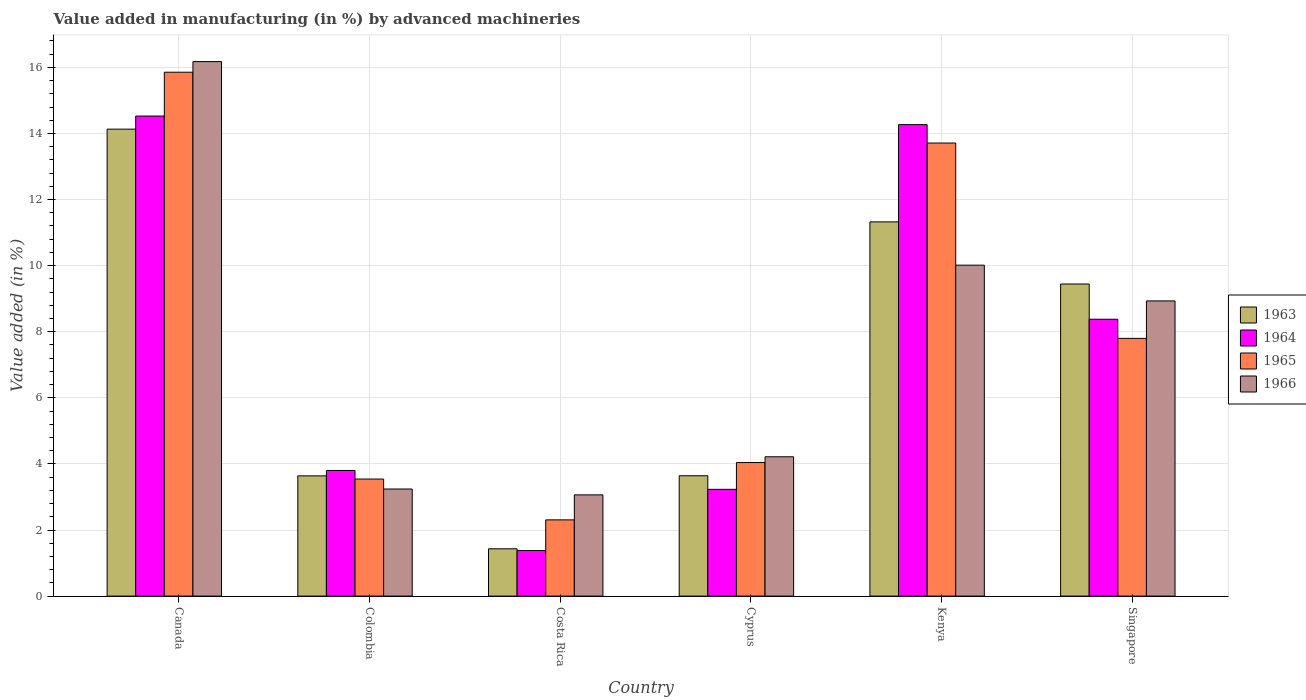How many different coloured bars are there?
Your response must be concise. 4. How many groups of bars are there?
Provide a short and direct response. 6. Are the number of bars per tick equal to the number of legend labels?
Ensure brevity in your answer.  Yes. How many bars are there on the 1st tick from the left?
Offer a terse response. 4. What is the label of the 6th group of bars from the left?
Give a very brief answer. Singapore. In how many cases, is the number of bars for a given country not equal to the number of legend labels?
Give a very brief answer. 0. What is the percentage of value added in manufacturing by advanced machineries in 1965 in Colombia?
Offer a very short reply. 3.54. Across all countries, what is the maximum percentage of value added in manufacturing by advanced machineries in 1966?
Your answer should be very brief. 16.17. Across all countries, what is the minimum percentage of value added in manufacturing by advanced machineries in 1966?
Make the answer very short. 3.06. In which country was the percentage of value added in manufacturing by advanced machineries in 1965 maximum?
Give a very brief answer. Canada. What is the total percentage of value added in manufacturing by advanced machineries in 1965 in the graph?
Offer a very short reply. 47.25. What is the difference between the percentage of value added in manufacturing by advanced machineries in 1965 in Colombia and that in Singapore?
Offer a terse response. -4.26. What is the difference between the percentage of value added in manufacturing by advanced machineries in 1966 in Costa Rica and the percentage of value added in manufacturing by advanced machineries in 1963 in Canada?
Make the answer very short. -11.07. What is the average percentage of value added in manufacturing by advanced machineries in 1964 per country?
Your answer should be compact. 7.6. What is the difference between the percentage of value added in manufacturing by advanced machineries of/in 1965 and percentage of value added in manufacturing by advanced machineries of/in 1963 in Cyprus?
Provide a short and direct response. 0.4. In how many countries, is the percentage of value added in manufacturing by advanced machineries in 1966 greater than 2 %?
Ensure brevity in your answer.  6. What is the ratio of the percentage of value added in manufacturing by advanced machineries in 1965 in Canada to that in Singapore?
Ensure brevity in your answer.  2.03. Is the percentage of value added in manufacturing by advanced machineries in 1966 in Colombia less than that in Costa Rica?
Ensure brevity in your answer.  No. What is the difference between the highest and the second highest percentage of value added in manufacturing by advanced machineries in 1963?
Provide a succinct answer. -1.88. What is the difference between the highest and the lowest percentage of value added in manufacturing by advanced machineries in 1964?
Offer a terse response. 13.15. In how many countries, is the percentage of value added in manufacturing by advanced machineries in 1963 greater than the average percentage of value added in manufacturing by advanced machineries in 1963 taken over all countries?
Provide a succinct answer. 3. Is it the case that in every country, the sum of the percentage of value added in manufacturing by advanced machineries in 1963 and percentage of value added in manufacturing by advanced machineries in 1964 is greater than the sum of percentage of value added in manufacturing by advanced machineries in 1965 and percentage of value added in manufacturing by advanced machineries in 1966?
Make the answer very short. No. What does the 1st bar from the left in Colombia represents?
Provide a short and direct response. 1963. What does the 3rd bar from the right in Costa Rica represents?
Give a very brief answer. 1964. Is it the case that in every country, the sum of the percentage of value added in manufacturing by advanced machineries in 1966 and percentage of value added in manufacturing by advanced machineries in 1965 is greater than the percentage of value added in manufacturing by advanced machineries in 1964?
Your response must be concise. Yes. What is the difference between two consecutive major ticks on the Y-axis?
Provide a short and direct response. 2. Are the values on the major ticks of Y-axis written in scientific E-notation?
Provide a short and direct response. No. How many legend labels are there?
Provide a succinct answer. 4. How are the legend labels stacked?
Provide a short and direct response. Vertical. What is the title of the graph?
Your response must be concise. Value added in manufacturing (in %) by advanced machineries. What is the label or title of the X-axis?
Make the answer very short. Country. What is the label or title of the Y-axis?
Keep it short and to the point. Value added (in %). What is the Value added (in %) of 1963 in Canada?
Provide a succinct answer. 14.13. What is the Value added (in %) in 1964 in Canada?
Your response must be concise. 14.53. What is the Value added (in %) of 1965 in Canada?
Your response must be concise. 15.85. What is the Value added (in %) in 1966 in Canada?
Your response must be concise. 16.17. What is the Value added (in %) of 1963 in Colombia?
Offer a terse response. 3.64. What is the Value added (in %) of 1964 in Colombia?
Keep it short and to the point. 3.8. What is the Value added (in %) of 1965 in Colombia?
Ensure brevity in your answer.  3.54. What is the Value added (in %) in 1966 in Colombia?
Provide a short and direct response. 3.24. What is the Value added (in %) in 1963 in Costa Rica?
Keep it short and to the point. 1.43. What is the Value added (in %) in 1964 in Costa Rica?
Your answer should be very brief. 1.38. What is the Value added (in %) of 1965 in Costa Rica?
Keep it short and to the point. 2.31. What is the Value added (in %) in 1966 in Costa Rica?
Keep it short and to the point. 3.06. What is the Value added (in %) of 1963 in Cyprus?
Provide a short and direct response. 3.64. What is the Value added (in %) of 1964 in Cyprus?
Keep it short and to the point. 3.23. What is the Value added (in %) in 1965 in Cyprus?
Provide a succinct answer. 4.04. What is the Value added (in %) of 1966 in Cyprus?
Offer a very short reply. 4.22. What is the Value added (in %) in 1963 in Kenya?
Your response must be concise. 11.32. What is the Value added (in %) of 1964 in Kenya?
Provide a short and direct response. 14.27. What is the Value added (in %) of 1965 in Kenya?
Offer a very short reply. 13.71. What is the Value added (in %) in 1966 in Kenya?
Your answer should be compact. 10.01. What is the Value added (in %) of 1963 in Singapore?
Provide a succinct answer. 9.44. What is the Value added (in %) of 1964 in Singapore?
Offer a terse response. 8.38. What is the Value added (in %) in 1965 in Singapore?
Give a very brief answer. 7.8. What is the Value added (in %) of 1966 in Singapore?
Make the answer very short. 8.93. Across all countries, what is the maximum Value added (in %) in 1963?
Offer a very short reply. 14.13. Across all countries, what is the maximum Value added (in %) in 1964?
Your answer should be compact. 14.53. Across all countries, what is the maximum Value added (in %) of 1965?
Provide a short and direct response. 15.85. Across all countries, what is the maximum Value added (in %) in 1966?
Make the answer very short. 16.17. Across all countries, what is the minimum Value added (in %) of 1963?
Your answer should be compact. 1.43. Across all countries, what is the minimum Value added (in %) in 1964?
Keep it short and to the point. 1.38. Across all countries, what is the minimum Value added (in %) of 1965?
Provide a succinct answer. 2.31. Across all countries, what is the minimum Value added (in %) in 1966?
Provide a short and direct response. 3.06. What is the total Value added (in %) in 1963 in the graph?
Keep it short and to the point. 43.61. What is the total Value added (in %) of 1964 in the graph?
Your answer should be compact. 45.58. What is the total Value added (in %) in 1965 in the graph?
Provide a short and direct response. 47.25. What is the total Value added (in %) of 1966 in the graph?
Give a very brief answer. 45.64. What is the difference between the Value added (in %) of 1963 in Canada and that in Colombia?
Your answer should be compact. 10.49. What is the difference between the Value added (in %) of 1964 in Canada and that in Colombia?
Ensure brevity in your answer.  10.72. What is the difference between the Value added (in %) in 1965 in Canada and that in Colombia?
Your answer should be compact. 12.31. What is the difference between the Value added (in %) in 1966 in Canada and that in Colombia?
Make the answer very short. 12.93. What is the difference between the Value added (in %) of 1963 in Canada and that in Costa Rica?
Keep it short and to the point. 12.7. What is the difference between the Value added (in %) in 1964 in Canada and that in Costa Rica?
Ensure brevity in your answer.  13.15. What is the difference between the Value added (in %) of 1965 in Canada and that in Costa Rica?
Give a very brief answer. 13.55. What is the difference between the Value added (in %) in 1966 in Canada and that in Costa Rica?
Your answer should be compact. 13.11. What is the difference between the Value added (in %) in 1963 in Canada and that in Cyprus?
Make the answer very short. 10.49. What is the difference between the Value added (in %) in 1964 in Canada and that in Cyprus?
Provide a short and direct response. 11.3. What is the difference between the Value added (in %) in 1965 in Canada and that in Cyprus?
Provide a succinct answer. 11.81. What is the difference between the Value added (in %) in 1966 in Canada and that in Cyprus?
Keep it short and to the point. 11.96. What is the difference between the Value added (in %) in 1963 in Canada and that in Kenya?
Give a very brief answer. 2.81. What is the difference between the Value added (in %) of 1964 in Canada and that in Kenya?
Your answer should be compact. 0.26. What is the difference between the Value added (in %) in 1965 in Canada and that in Kenya?
Offer a terse response. 2.14. What is the difference between the Value added (in %) of 1966 in Canada and that in Kenya?
Give a very brief answer. 6.16. What is the difference between the Value added (in %) in 1963 in Canada and that in Singapore?
Offer a very short reply. 4.69. What is the difference between the Value added (in %) in 1964 in Canada and that in Singapore?
Your answer should be compact. 6.15. What is the difference between the Value added (in %) of 1965 in Canada and that in Singapore?
Ensure brevity in your answer.  8.05. What is the difference between the Value added (in %) of 1966 in Canada and that in Singapore?
Keep it short and to the point. 7.24. What is the difference between the Value added (in %) of 1963 in Colombia and that in Costa Rica?
Keep it short and to the point. 2.21. What is the difference between the Value added (in %) of 1964 in Colombia and that in Costa Rica?
Your answer should be very brief. 2.42. What is the difference between the Value added (in %) in 1965 in Colombia and that in Costa Rica?
Keep it short and to the point. 1.24. What is the difference between the Value added (in %) of 1966 in Colombia and that in Costa Rica?
Provide a short and direct response. 0.18. What is the difference between the Value added (in %) in 1963 in Colombia and that in Cyprus?
Give a very brief answer. -0. What is the difference between the Value added (in %) in 1964 in Colombia and that in Cyprus?
Offer a terse response. 0.57. What is the difference between the Value added (in %) in 1965 in Colombia and that in Cyprus?
Keep it short and to the point. -0.5. What is the difference between the Value added (in %) in 1966 in Colombia and that in Cyprus?
Provide a short and direct response. -0.97. What is the difference between the Value added (in %) of 1963 in Colombia and that in Kenya?
Your answer should be very brief. -7.69. What is the difference between the Value added (in %) in 1964 in Colombia and that in Kenya?
Keep it short and to the point. -10.47. What is the difference between the Value added (in %) in 1965 in Colombia and that in Kenya?
Your answer should be compact. -10.17. What is the difference between the Value added (in %) of 1966 in Colombia and that in Kenya?
Offer a very short reply. -6.77. What is the difference between the Value added (in %) of 1963 in Colombia and that in Singapore?
Make the answer very short. -5.81. What is the difference between the Value added (in %) in 1964 in Colombia and that in Singapore?
Keep it short and to the point. -4.58. What is the difference between the Value added (in %) in 1965 in Colombia and that in Singapore?
Your answer should be compact. -4.26. What is the difference between the Value added (in %) in 1966 in Colombia and that in Singapore?
Ensure brevity in your answer.  -5.69. What is the difference between the Value added (in %) in 1963 in Costa Rica and that in Cyprus?
Make the answer very short. -2.21. What is the difference between the Value added (in %) of 1964 in Costa Rica and that in Cyprus?
Keep it short and to the point. -1.85. What is the difference between the Value added (in %) of 1965 in Costa Rica and that in Cyprus?
Give a very brief answer. -1.73. What is the difference between the Value added (in %) in 1966 in Costa Rica and that in Cyprus?
Keep it short and to the point. -1.15. What is the difference between the Value added (in %) of 1963 in Costa Rica and that in Kenya?
Your response must be concise. -9.89. What is the difference between the Value added (in %) of 1964 in Costa Rica and that in Kenya?
Offer a very short reply. -12.89. What is the difference between the Value added (in %) of 1965 in Costa Rica and that in Kenya?
Make the answer very short. -11.4. What is the difference between the Value added (in %) of 1966 in Costa Rica and that in Kenya?
Ensure brevity in your answer.  -6.95. What is the difference between the Value added (in %) of 1963 in Costa Rica and that in Singapore?
Give a very brief answer. -8.01. What is the difference between the Value added (in %) of 1964 in Costa Rica and that in Singapore?
Offer a very short reply. -7. What is the difference between the Value added (in %) of 1965 in Costa Rica and that in Singapore?
Provide a succinct answer. -5.49. What is the difference between the Value added (in %) of 1966 in Costa Rica and that in Singapore?
Your response must be concise. -5.87. What is the difference between the Value added (in %) of 1963 in Cyprus and that in Kenya?
Ensure brevity in your answer.  -7.68. What is the difference between the Value added (in %) in 1964 in Cyprus and that in Kenya?
Keep it short and to the point. -11.04. What is the difference between the Value added (in %) in 1965 in Cyprus and that in Kenya?
Provide a succinct answer. -9.67. What is the difference between the Value added (in %) in 1966 in Cyprus and that in Kenya?
Offer a terse response. -5.8. What is the difference between the Value added (in %) in 1963 in Cyprus and that in Singapore?
Offer a very short reply. -5.8. What is the difference between the Value added (in %) of 1964 in Cyprus and that in Singapore?
Your response must be concise. -5.15. What is the difference between the Value added (in %) of 1965 in Cyprus and that in Singapore?
Provide a succinct answer. -3.76. What is the difference between the Value added (in %) in 1966 in Cyprus and that in Singapore?
Your answer should be compact. -4.72. What is the difference between the Value added (in %) in 1963 in Kenya and that in Singapore?
Ensure brevity in your answer.  1.88. What is the difference between the Value added (in %) in 1964 in Kenya and that in Singapore?
Give a very brief answer. 5.89. What is the difference between the Value added (in %) of 1965 in Kenya and that in Singapore?
Your response must be concise. 5.91. What is the difference between the Value added (in %) of 1966 in Kenya and that in Singapore?
Make the answer very short. 1.08. What is the difference between the Value added (in %) in 1963 in Canada and the Value added (in %) in 1964 in Colombia?
Your response must be concise. 10.33. What is the difference between the Value added (in %) in 1963 in Canada and the Value added (in %) in 1965 in Colombia?
Your response must be concise. 10.59. What is the difference between the Value added (in %) of 1963 in Canada and the Value added (in %) of 1966 in Colombia?
Give a very brief answer. 10.89. What is the difference between the Value added (in %) in 1964 in Canada and the Value added (in %) in 1965 in Colombia?
Ensure brevity in your answer.  10.98. What is the difference between the Value added (in %) of 1964 in Canada and the Value added (in %) of 1966 in Colombia?
Give a very brief answer. 11.29. What is the difference between the Value added (in %) of 1965 in Canada and the Value added (in %) of 1966 in Colombia?
Provide a short and direct response. 12.61. What is the difference between the Value added (in %) of 1963 in Canada and the Value added (in %) of 1964 in Costa Rica?
Make the answer very short. 12.75. What is the difference between the Value added (in %) in 1963 in Canada and the Value added (in %) in 1965 in Costa Rica?
Offer a very short reply. 11.82. What is the difference between the Value added (in %) in 1963 in Canada and the Value added (in %) in 1966 in Costa Rica?
Your response must be concise. 11.07. What is the difference between the Value added (in %) in 1964 in Canada and the Value added (in %) in 1965 in Costa Rica?
Offer a terse response. 12.22. What is the difference between the Value added (in %) in 1964 in Canada and the Value added (in %) in 1966 in Costa Rica?
Offer a terse response. 11.46. What is the difference between the Value added (in %) of 1965 in Canada and the Value added (in %) of 1966 in Costa Rica?
Offer a very short reply. 12.79. What is the difference between the Value added (in %) in 1963 in Canada and the Value added (in %) in 1964 in Cyprus?
Your answer should be compact. 10.9. What is the difference between the Value added (in %) of 1963 in Canada and the Value added (in %) of 1965 in Cyprus?
Give a very brief answer. 10.09. What is the difference between the Value added (in %) in 1963 in Canada and the Value added (in %) in 1966 in Cyprus?
Your answer should be very brief. 9.92. What is the difference between the Value added (in %) in 1964 in Canada and the Value added (in %) in 1965 in Cyprus?
Your response must be concise. 10.49. What is the difference between the Value added (in %) in 1964 in Canada and the Value added (in %) in 1966 in Cyprus?
Provide a short and direct response. 10.31. What is the difference between the Value added (in %) in 1965 in Canada and the Value added (in %) in 1966 in Cyprus?
Give a very brief answer. 11.64. What is the difference between the Value added (in %) in 1963 in Canada and the Value added (in %) in 1964 in Kenya?
Give a very brief answer. -0.14. What is the difference between the Value added (in %) in 1963 in Canada and the Value added (in %) in 1965 in Kenya?
Provide a short and direct response. 0.42. What is the difference between the Value added (in %) of 1963 in Canada and the Value added (in %) of 1966 in Kenya?
Provide a succinct answer. 4.12. What is the difference between the Value added (in %) in 1964 in Canada and the Value added (in %) in 1965 in Kenya?
Your response must be concise. 0.82. What is the difference between the Value added (in %) in 1964 in Canada and the Value added (in %) in 1966 in Kenya?
Offer a very short reply. 4.51. What is the difference between the Value added (in %) of 1965 in Canada and the Value added (in %) of 1966 in Kenya?
Give a very brief answer. 5.84. What is the difference between the Value added (in %) in 1963 in Canada and the Value added (in %) in 1964 in Singapore?
Provide a short and direct response. 5.75. What is the difference between the Value added (in %) in 1963 in Canada and the Value added (in %) in 1965 in Singapore?
Your answer should be very brief. 6.33. What is the difference between the Value added (in %) in 1963 in Canada and the Value added (in %) in 1966 in Singapore?
Provide a succinct answer. 5.2. What is the difference between the Value added (in %) of 1964 in Canada and the Value added (in %) of 1965 in Singapore?
Provide a short and direct response. 6.73. What is the difference between the Value added (in %) in 1964 in Canada and the Value added (in %) in 1966 in Singapore?
Your answer should be very brief. 5.59. What is the difference between the Value added (in %) in 1965 in Canada and the Value added (in %) in 1966 in Singapore?
Your answer should be compact. 6.92. What is the difference between the Value added (in %) of 1963 in Colombia and the Value added (in %) of 1964 in Costa Rica?
Provide a succinct answer. 2.26. What is the difference between the Value added (in %) of 1963 in Colombia and the Value added (in %) of 1965 in Costa Rica?
Provide a short and direct response. 1.33. What is the difference between the Value added (in %) of 1963 in Colombia and the Value added (in %) of 1966 in Costa Rica?
Make the answer very short. 0.57. What is the difference between the Value added (in %) in 1964 in Colombia and the Value added (in %) in 1965 in Costa Rica?
Your answer should be very brief. 1.49. What is the difference between the Value added (in %) of 1964 in Colombia and the Value added (in %) of 1966 in Costa Rica?
Give a very brief answer. 0.74. What is the difference between the Value added (in %) in 1965 in Colombia and the Value added (in %) in 1966 in Costa Rica?
Your answer should be very brief. 0.48. What is the difference between the Value added (in %) of 1963 in Colombia and the Value added (in %) of 1964 in Cyprus?
Offer a terse response. 0.41. What is the difference between the Value added (in %) of 1963 in Colombia and the Value added (in %) of 1965 in Cyprus?
Make the answer very short. -0.4. What is the difference between the Value added (in %) in 1963 in Colombia and the Value added (in %) in 1966 in Cyprus?
Make the answer very short. -0.58. What is the difference between the Value added (in %) of 1964 in Colombia and the Value added (in %) of 1965 in Cyprus?
Your answer should be very brief. -0.24. What is the difference between the Value added (in %) in 1964 in Colombia and the Value added (in %) in 1966 in Cyprus?
Give a very brief answer. -0.41. What is the difference between the Value added (in %) of 1965 in Colombia and the Value added (in %) of 1966 in Cyprus?
Your response must be concise. -0.67. What is the difference between the Value added (in %) in 1963 in Colombia and the Value added (in %) in 1964 in Kenya?
Give a very brief answer. -10.63. What is the difference between the Value added (in %) of 1963 in Colombia and the Value added (in %) of 1965 in Kenya?
Your answer should be very brief. -10.07. What is the difference between the Value added (in %) of 1963 in Colombia and the Value added (in %) of 1966 in Kenya?
Your answer should be compact. -6.38. What is the difference between the Value added (in %) of 1964 in Colombia and the Value added (in %) of 1965 in Kenya?
Make the answer very short. -9.91. What is the difference between the Value added (in %) in 1964 in Colombia and the Value added (in %) in 1966 in Kenya?
Your answer should be very brief. -6.21. What is the difference between the Value added (in %) of 1965 in Colombia and the Value added (in %) of 1966 in Kenya?
Keep it short and to the point. -6.47. What is the difference between the Value added (in %) in 1963 in Colombia and the Value added (in %) in 1964 in Singapore?
Your answer should be very brief. -4.74. What is the difference between the Value added (in %) in 1963 in Colombia and the Value added (in %) in 1965 in Singapore?
Offer a very short reply. -4.16. What is the difference between the Value added (in %) in 1963 in Colombia and the Value added (in %) in 1966 in Singapore?
Your response must be concise. -5.29. What is the difference between the Value added (in %) of 1964 in Colombia and the Value added (in %) of 1965 in Singapore?
Offer a very short reply. -4. What is the difference between the Value added (in %) in 1964 in Colombia and the Value added (in %) in 1966 in Singapore?
Give a very brief answer. -5.13. What is the difference between the Value added (in %) in 1965 in Colombia and the Value added (in %) in 1966 in Singapore?
Your answer should be very brief. -5.39. What is the difference between the Value added (in %) of 1963 in Costa Rica and the Value added (in %) of 1964 in Cyprus?
Provide a short and direct response. -1.8. What is the difference between the Value added (in %) of 1963 in Costa Rica and the Value added (in %) of 1965 in Cyprus?
Offer a very short reply. -2.61. What is the difference between the Value added (in %) in 1963 in Costa Rica and the Value added (in %) in 1966 in Cyprus?
Provide a succinct answer. -2.78. What is the difference between the Value added (in %) in 1964 in Costa Rica and the Value added (in %) in 1965 in Cyprus?
Offer a terse response. -2.66. What is the difference between the Value added (in %) in 1964 in Costa Rica and the Value added (in %) in 1966 in Cyprus?
Make the answer very short. -2.84. What is the difference between the Value added (in %) of 1965 in Costa Rica and the Value added (in %) of 1966 in Cyprus?
Your response must be concise. -1.91. What is the difference between the Value added (in %) in 1963 in Costa Rica and the Value added (in %) in 1964 in Kenya?
Keep it short and to the point. -12.84. What is the difference between the Value added (in %) in 1963 in Costa Rica and the Value added (in %) in 1965 in Kenya?
Your answer should be compact. -12.28. What is the difference between the Value added (in %) of 1963 in Costa Rica and the Value added (in %) of 1966 in Kenya?
Ensure brevity in your answer.  -8.58. What is the difference between the Value added (in %) of 1964 in Costa Rica and the Value added (in %) of 1965 in Kenya?
Your answer should be very brief. -12.33. What is the difference between the Value added (in %) in 1964 in Costa Rica and the Value added (in %) in 1966 in Kenya?
Your answer should be compact. -8.64. What is the difference between the Value added (in %) of 1965 in Costa Rica and the Value added (in %) of 1966 in Kenya?
Give a very brief answer. -7.71. What is the difference between the Value added (in %) in 1963 in Costa Rica and the Value added (in %) in 1964 in Singapore?
Make the answer very short. -6.95. What is the difference between the Value added (in %) of 1963 in Costa Rica and the Value added (in %) of 1965 in Singapore?
Your response must be concise. -6.37. What is the difference between the Value added (in %) of 1963 in Costa Rica and the Value added (in %) of 1966 in Singapore?
Offer a very short reply. -7.5. What is the difference between the Value added (in %) in 1964 in Costa Rica and the Value added (in %) in 1965 in Singapore?
Your answer should be compact. -6.42. What is the difference between the Value added (in %) in 1964 in Costa Rica and the Value added (in %) in 1966 in Singapore?
Your response must be concise. -7.55. What is the difference between the Value added (in %) of 1965 in Costa Rica and the Value added (in %) of 1966 in Singapore?
Your response must be concise. -6.63. What is the difference between the Value added (in %) in 1963 in Cyprus and the Value added (in %) in 1964 in Kenya?
Offer a very short reply. -10.63. What is the difference between the Value added (in %) of 1963 in Cyprus and the Value added (in %) of 1965 in Kenya?
Your answer should be very brief. -10.07. What is the difference between the Value added (in %) in 1963 in Cyprus and the Value added (in %) in 1966 in Kenya?
Give a very brief answer. -6.37. What is the difference between the Value added (in %) of 1964 in Cyprus and the Value added (in %) of 1965 in Kenya?
Offer a terse response. -10.48. What is the difference between the Value added (in %) in 1964 in Cyprus and the Value added (in %) in 1966 in Kenya?
Keep it short and to the point. -6.78. What is the difference between the Value added (in %) in 1965 in Cyprus and the Value added (in %) in 1966 in Kenya?
Make the answer very short. -5.97. What is the difference between the Value added (in %) of 1963 in Cyprus and the Value added (in %) of 1964 in Singapore?
Keep it short and to the point. -4.74. What is the difference between the Value added (in %) in 1963 in Cyprus and the Value added (in %) in 1965 in Singapore?
Offer a very short reply. -4.16. What is the difference between the Value added (in %) of 1963 in Cyprus and the Value added (in %) of 1966 in Singapore?
Provide a short and direct response. -5.29. What is the difference between the Value added (in %) of 1964 in Cyprus and the Value added (in %) of 1965 in Singapore?
Give a very brief answer. -4.57. What is the difference between the Value added (in %) of 1964 in Cyprus and the Value added (in %) of 1966 in Singapore?
Your answer should be compact. -5.7. What is the difference between the Value added (in %) in 1965 in Cyprus and the Value added (in %) in 1966 in Singapore?
Give a very brief answer. -4.89. What is the difference between the Value added (in %) of 1963 in Kenya and the Value added (in %) of 1964 in Singapore?
Ensure brevity in your answer.  2.95. What is the difference between the Value added (in %) in 1963 in Kenya and the Value added (in %) in 1965 in Singapore?
Provide a short and direct response. 3.52. What is the difference between the Value added (in %) in 1963 in Kenya and the Value added (in %) in 1966 in Singapore?
Keep it short and to the point. 2.39. What is the difference between the Value added (in %) of 1964 in Kenya and the Value added (in %) of 1965 in Singapore?
Ensure brevity in your answer.  6.47. What is the difference between the Value added (in %) in 1964 in Kenya and the Value added (in %) in 1966 in Singapore?
Offer a very short reply. 5.33. What is the difference between the Value added (in %) of 1965 in Kenya and the Value added (in %) of 1966 in Singapore?
Offer a very short reply. 4.78. What is the average Value added (in %) of 1963 per country?
Offer a terse response. 7.27. What is the average Value added (in %) of 1964 per country?
Provide a succinct answer. 7.6. What is the average Value added (in %) in 1965 per country?
Your response must be concise. 7.88. What is the average Value added (in %) of 1966 per country?
Offer a very short reply. 7.61. What is the difference between the Value added (in %) of 1963 and Value added (in %) of 1964 in Canada?
Provide a short and direct response. -0.4. What is the difference between the Value added (in %) in 1963 and Value added (in %) in 1965 in Canada?
Ensure brevity in your answer.  -1.72. What is the difference between the Value added (in %) of 1963 and Value added (in %) of 1966 in Canada?
Your answer should be very brief. -2.04. What is the difference between the Value added (in %) of 1964 and Value added (in %) of 1965 in Canada?
Provide a succinct answer. -1.33. What is the difference between the Value added (in %) of 1964 and Value added (in %) of 1966 in Canada?
Provide a short and direct response. -1.65. What is the difference between the Value added (in %) in 1965 and Value added (in %) in 1966 in Canada?
Ensure brevity in your answer.  -0.32. What is the difference between the Value added (in %) of 1963 and Value added (in %) of 1964 in Colombia?
Offer a very short reply. -0.16. What is the difference between the Value added (in %) of 1963 and Value added (in %) of 1965 in Colombia?
Your answer should be very brief. 0.1. What is the difference between the Value added (in %) in 1963 and Value added (in %) in 1966 in Colombia?
Provide a short and direct response. 0.4. What is the difference between the Value added (in %) of 1964 and Value added (in %) of 1965 in Colombia?
Keep it short and to the point. 0.26. What is the difference between the Value added (in %) of 1964 and Value added (in %) of 1966 in Colombia?
Keep it short and to the point. 0.56. What is the difference between the Value added (in %) in 1965 and Value added (in %) in 1966 in Colombia?
Ensure brevity in your answer.  0.3. What is the difference between the Value added (in %) in 1963 and Value added (in %) in 1964 in Costa Rica?
Provide a succinct answer. 0.05. What is the difference between the Value added (in %) of 1963 and Value added (in %) of 1965 in Costa Rica?
Make the answer very short. -0.88. What is the difference between the Value added (in %) in 1963 and Value added (in %) in 1966 in Costa Rica?
Make the answer very short. -1.63. What is the difference between the Value added (in %) of 1964 and Value added (in %) of 1965 in Costa Rica?
Ensure brevity in your answer.  -0.93. What is the difference between the Value added (in %) in 1964 and Value added (in %) in 1966 in Costa Rica?
Provide a succinct answer. -1.69. What is the difference between the Value added (in %) in 1965 and Value added (in %) in 1966 in Costa Rica?
Your response must be concise. -0.76. What is the difference between the Value added (in %) in 1963 and Value added (in %) in 1964 in Cyprus?
Provide a succinct answer. 0.41. What is the difference between the Value added (in %) of 1963 and Value added (in %) of 1965 in Cyprus?
Make the answer very short. -0.4. What is the difference between the Value added (in %) in 1963 and Value added (in %) in 1966 in Cyprus?
Offer a very short reply. -0.57. What is the difference between the Value added (in %) of 1964 and Value added (in %) of 1965 in Cyprus?
Offer a terse response. -0.81. What is the difference between the Value added (in %) in 1964 and Value added (in %) in 1966 in Cyprus?
Your answer should be very brief. -0.98. What is the difference between the Value added (in %) in 1965 and Value added (in %) in 1966 in Cyprus?
Offer a terse response. -0.17. What is the difference between the Value added (in %) in 1963 and Value added (in %) in 1964 in Kenya?
Your answer should be very brief. -2.94. What is the difference between the Value added (in %) of 1963 and Value added (in %) of 1965 in Kenya?
Your answer should be very brief. -2.39. What is the difference between the Value added (in %) of 1963 and Value added (in %) of 1966 in Kenya?
Give a very brief answer. 1.31. What is the difference between the Value added (in %) of 1964 and Value added (in %) of 1965 in Kenya?
Offer a terse response. 0.56. What is the difference between the Value added (in %) in 1964 and Value added (in %) in 1966 in Kenya?
Offer a terse response. 4.25. What is the difference between the Value added (in %) of 1965 and Value added (in %) of 1966 in Kenya?
Keep it short and to the point. 3.7. What is the difference between the Value added (in %) of 1963 and Value added (in %) of 1964 in Singapore?
Ensure brevity in your answer.  1.07. What is the difference between the Value added (in %) of 1963 and Value added (in %) of 1965 in Singapore?
Your answer should be very brief. 1.64. What is the difference between the Value added (in %) in 1963 and Value added (in %) in 1966 in Singapore?
Your response must be concise. 0.51. What is the difference between the Value added (in %) of 1964 and Value added (in %) of 1965 in Singapore?
Provide a succinct answer. 0.58. What is the difference between the Value added (in %) of 1964 and Value added (in %) of 1966 in Singapore?
Make the answer very short. -0.55. What is the difference between the Value added (in %) of 1965 and Value added (in %) of 1966 in Singapore?
Provide a short and direct response. -1.13. What is the ratio of the Value added (in %) in 1963 in Canada to that in Colombia?
Provide a succinct answer. 3.88. What is the ratio of the Value added (in %) in 1964 in Canada to that in Colombia?
Your response must be concise. 3.82. What is the ratio of the Value added (in %) in 1965 in Canada to that in Colombia?
Provide a succinct answer. 4.48. What is the ratio of the Value added (in %) of 1966 in Canada to that in Colombia?
Your answer should be compact. 4.99. What is the ratio of the Value added (in %) in 1963 in Canada to that in Costa Rica?
Offer a terse response. 9.87. What is the ratio of the Value added (in %) in 1964 in Canada to that in Costa Rica?
Ensure brevity in your answer.  10.54. What is the ratio of the Value added (in %) of 1965 in Canada to that in Costa Rica?
Give a very brief answer. 6.87. What is the ratio of the Value added (in %) in 1966 in Canada to that in Costa Rica?
Ensure brevity in your answer.  5.28. What is the ratio of the Value added (in %) in 1963 in Canada to that in Cyprus?
Offer a terse response. 3.88. What is the ratio of the Value added (in %) of 1964 in Canada to that in Cyprus?
Offer a terse response. 4.5. What is the ratio of the Value added (in %) in 1965 in Canada to that in Cyprus?
Make the answer very short. 3.92. What is the ratio of the Value added (in %) of 1966 in Canada to that in Cyprus?
Offer a terse response. 3.84. What is the ratio of the Value added (in %) of 1963 in Canada to that in Kenya?
Provide a succinct answer. 1.25. What is the ratio of the Value added (in %) in 1964 in Canada to that in Kenya?
Offer a very short reply. 1.02. What is the ratio of the Value added (in %) of 1965 in Canada to that in Kenya?
Keep it short and to the point. 1.16. What is the ratio of the Value added (in %) of 1966 in Canada to that in Kenya?
Give a very brief answer. 1.62. What is the ratio of the Value added (in %) in 1963 in Canada to that in Singapore?
Offer a very short reply. 1.5. What is the ratio of the Value added (in %) in 1964 in Canada to that in Singapore?
Your answer should be very brief. 1.73. What is the ratio of the Value added (in %) in 1965 in Canada to that in Singapore?
Make the answer very short. 2.03. What is the ratio of the Value added (in %) in 1966 in Canada to that in Singapore?
Offer a very short reply. 1.81. What is the ratio of the Value added (in %) in 1963 in Colombia to that in Costa Rica?
Provide a short and direct response. 2.54. What is the ratio of the Value added (in %) of 1964 in Colombia to that in Costa Rica?
Your response must be concise. 2.76. What is the ratio of the Value added (in %) in 1965 in Colombia to that in Costa Rica?
Your answer should be compact. 1.54. What is the ratio of the Value added (in %) in 1966 in Colombia to that in Costa Rica?
Offer a very short reply. 1.06. What is the ratio of the Value added (in %) of 1963 in Colombia to that in Cyprus?
Provide a short and direct response. 1. What is the ratio of the Value added (in %) of 1964 in Colombia to that in Cyprus?
Keep it short and to the point. 1.18. What is the ratio of the Value added (in %) in 1965 in Colombia to that in Cyprus?
Offer a terse response. 0.88. What is the ratio of the Value added (in %) of 1966 in Colombia to that in Cyprus?
Offer a terse response. 0.77. What is the ratio of the Value added (in %) of 1963 in Colombia to that in Kenya?
Keep it short and to the point. 0.32. What is the ratio of the Value added (in %) of 1964 in Colombia to that in Kenya?
Your answer should be very brief. 0.27. What is the ratio of the Value added (in %) of 1965 in Colombia to that in Kenya?
Your answer should be compact. 0.26. What is the ratio of the Value added (in %) in 1966 in Colombia to that in Kenya?
Your answer should be very brief. 0.32. What is the ratio of the Value added (in %) in 1963 in Colombia to that in Singapore?
Provide a short and direct response. 0.39. What is the ratio of the Value added (in %) in 1964 in Colombia to that in Singapore?
Make the answer very short. 0.45. What is the ratio of the Value added (in %) of 1965 in Colombia to that in Singapore?
Make the answer very short. 0.45. What is the ratio of the Value added (in %) in 1966 in Colombia to that in Singapore?
Your response must be concise. 0.36. What is the ratio of the Value added (in %) in 1963 in Costa Rica to that in Cyprus?
Offer a terse response. 0.39. What is the ratio of the Value added (in %) of 1964 in Costa Rica to that in Cyprus?
Provide a short and direct response. 0.43. What is the ratio of the Value added (in %) of 1965 in Costa Rica to that in Cyprus?
Your answer should be very brief. 0.57. What is the ratio of the Value added (in %) in 1966 in Costa Rica to that in Cyprus?
Provide a short and direct response. 0.73. What is the ratio of the Value added (in %) in 1963 in Costa Rica to that in Kenya?
Give a very brief answer. 0.13. What is the ratio of the Value added (in %) in 1964 in Costa Rica to that in Kenya?
Your answer should be very brief. 0.1. What is the ratio of the Value added (in %) in 1965 in Costa Rica to that in Kenya?
Offer a terse response. 0.17. What is the ratio of the Value added (in %) of 1966 in Costa Rica to that in Kenya?
Your response must be concise. 0.31. What is the ratio of the Value added (in %) of 1963 in Costa Rica to that in Singapore?
Make the answer very short. 0.15. What is the ratio of the Value added (in %) in 1964 in Costa Rica to that in Singapore?
Offer a very short reply. 0.16. What is the ratio of the Value added (in %) in 1965 in Costa Rica to that in Singapore?
Offer a terse response. 0.3. What is the ratio of the Value added (in %) in 1966 in Costa Rica to that in Singapore?
Keep it short and to the point. 0.34. What is the ratio of the Value added (in %) in 1963 in Cyprus to that in Kenya?
Offer a very short reply. 0.32. What is the ratio of the Value added (in %) in 1964 in Cyprus to that in Kenya?
Provide a short and direct response. 0.23. What is the ratio of the Value added (in %) in 1965 in Cyprus to that in Kenya?
Give a very brief answer. 0.29. What is the ratio of the Value added (in %) in 1966 in Cyprus to that in Kenya?
Provide a succinct answer. 0.42. What is the ratio of the Value added (in %) in 1963 in Cyprus to that in Singapore?
Provide a short and direct response. 0.39. What is the ratio of the Value added (in %) of 1964 in Cyprus to that in Singapore?
Offer a very short reply. 0.39. What is the ratio of the Value added (in %) in 1965 in Cyprus to that in Singapore?
Your response must be concise. 0.52. What is the ratio of the Value added (in %) in 1966 in Cyprus to that in Singapore?
Give a very brief answer. 0.47. What is the ratio of the Value added (in %) in 1963 in Kenya to that in Singapore?
Keep it short and to the point. 1.2. What is the ratio of the Value added (in %) of 1964 in Kenya to that in Singapore?
Keep it short and to the point. 1.7. What is the ratio of the Value added (in %) of 1965 in Kenya to that in Singapore?
Offer a very short reply. 1.76. What is the ratio of the Value added (in %) of 1966 in Kenya to that in Singapore?
Your answer should be very brief. 1.12. What is the difference between the highest and the second highest Value added (in %) in 1963?
Provide a succinct answer. 2.81. What is the difference between the highest and the second highest Value added (in %) in 1964?
Your answer should be very brief. 0.26. What is the difference between the highest and the second highest Value added (in %) of 1965?
Make the answer very short. 2.14. What is the difference between the highest and the second highest Value added (in %) in 1966?
Offer a terse response. 6.16. What is the difference between the highest and the lowest Value added (in %) in 1963?
Your answer should be very brief. 12.7. What is the difference between the highest and the lowest Value added (in %) of 1964?
Provide a succinct answer. 13.15. What is the difference between the highest and the lowest Value added (in %) of 1965?
Provide a succinct answer. 13.55. What is the difference between the highest and the lowest Value added (in %) of 1966?
Your answer should be very brief. 13.11. 